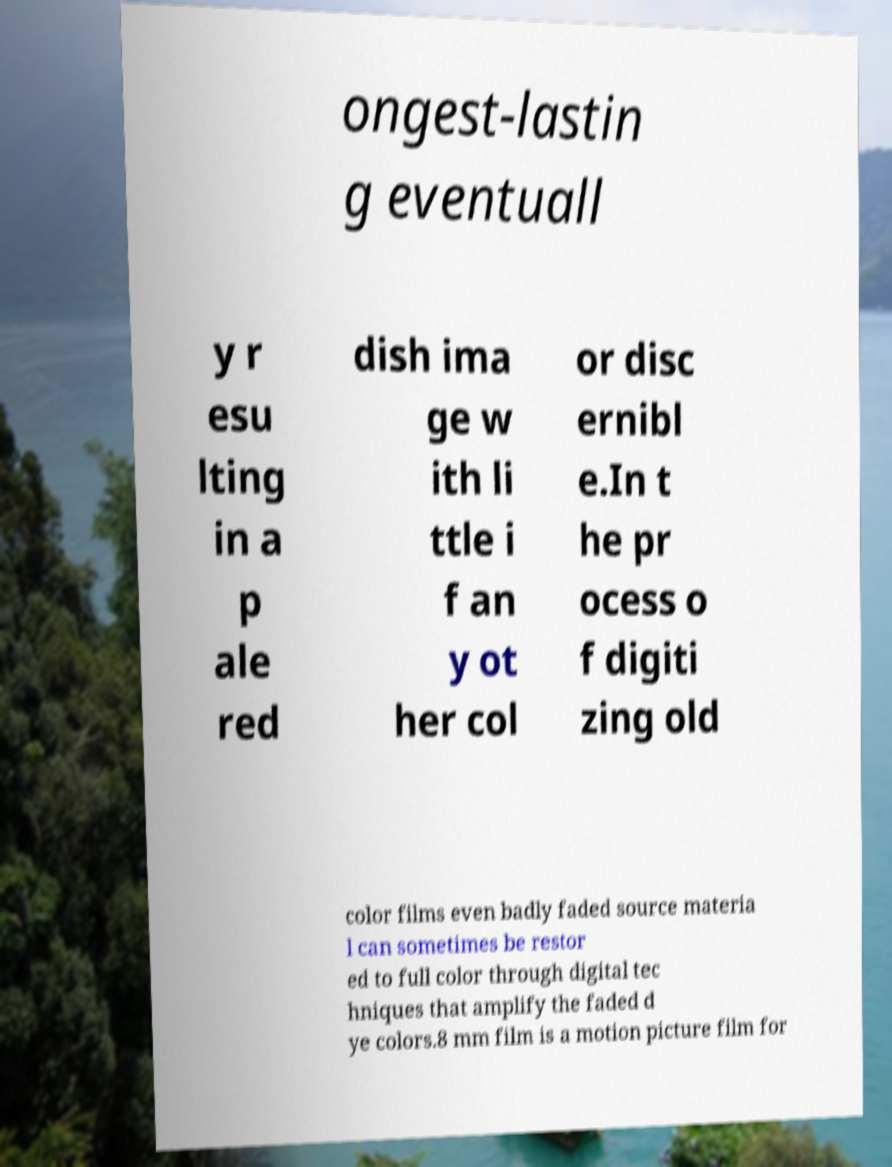There's text embedded in this image that I need extracted. Can you transcribe it verbatim? ongest-lastin g eventuall y r esu lting in a p ale red dish ima ge w ith li ttle i f an y ot her col or disc ernibl e.In t he pr ocess o f digiti zing old color films even badly faded source materia l can sometimes be restor ed to full color through digital tec hniques that amplify the faded d ye colors.8 mm film is a motion picture film for 